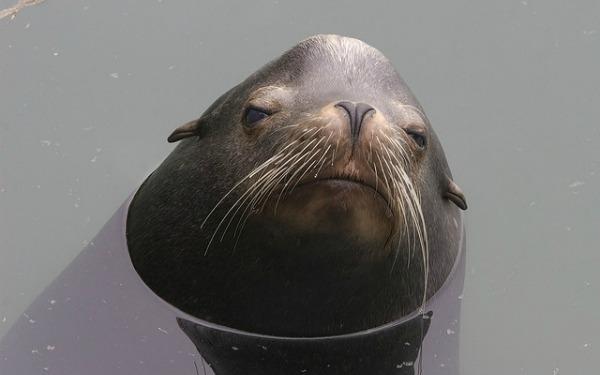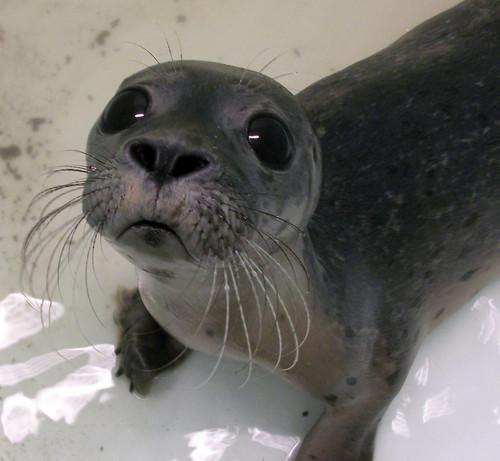The first image is the image on the left, the second image is the image on the right. For the images displayed, is the sentence "In the right image there is a single seal looking at the camera." factually correct? Answer yes or no. Yes. The first image is the image on the left, the second image is the image on the right. For the images displayed, is the sentence "One image shows a seal lying on its side on a flat, unelevated surface with its head raised and turned to the camera." factually correct? Answer yes or no. No. 